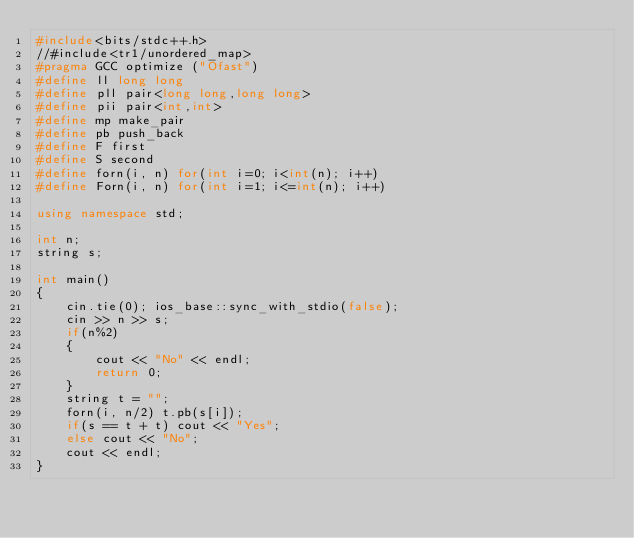<code> <loc_0><loc_0><loc_500><loc_500><_C++_>#include<bits/stdc++.h>
//#include<tr1/unordered_map>
#pragma GCC optimize ("Ofast")
#define ll long long
#define pll pair<long long,long long>
#define pii pair<int,int>
#define mp make_pair
#define pb push_back
#define F first
#define S second
#define forn(i, n) for(int i=0; i<int(n); i++)
#define Forn(i, n) for(int i=1; i<=int(n); i++)

using namespace std;

int n;
string s;

int main()
{
    cin.tie(0); ios_base::sync_with_stdio(false);
    cin >> n >> s;
    if(n%2)
    {
        cout << "No" << endl;
        return 0;
    }
    string t = "";
    forn(i, n/2) t.pb(s[i]);
    if(s == t + t) cout << "Yes";
    else cout << "No";
    cout << endl;
}
</code> 